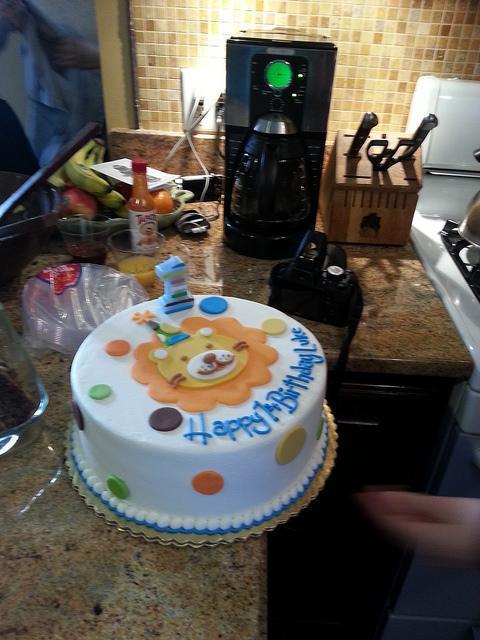Is the statement "The cake is enclosed by the oven." accurate regarding the image?
Answer yes or no. No. Is this affirmation: "The cake is above the oven." correct?
Answer yes or no. No. Is the statement "The oven is beneath the cake." accurate regarding the image?
Answer yes or no. No. Is the statement "The cake is in front of the oven." accurate regarding the image?
Answer yes or no. No. Is this affirmation: "The oven is in front of the cake." correct?
Answer yes or no. No. 